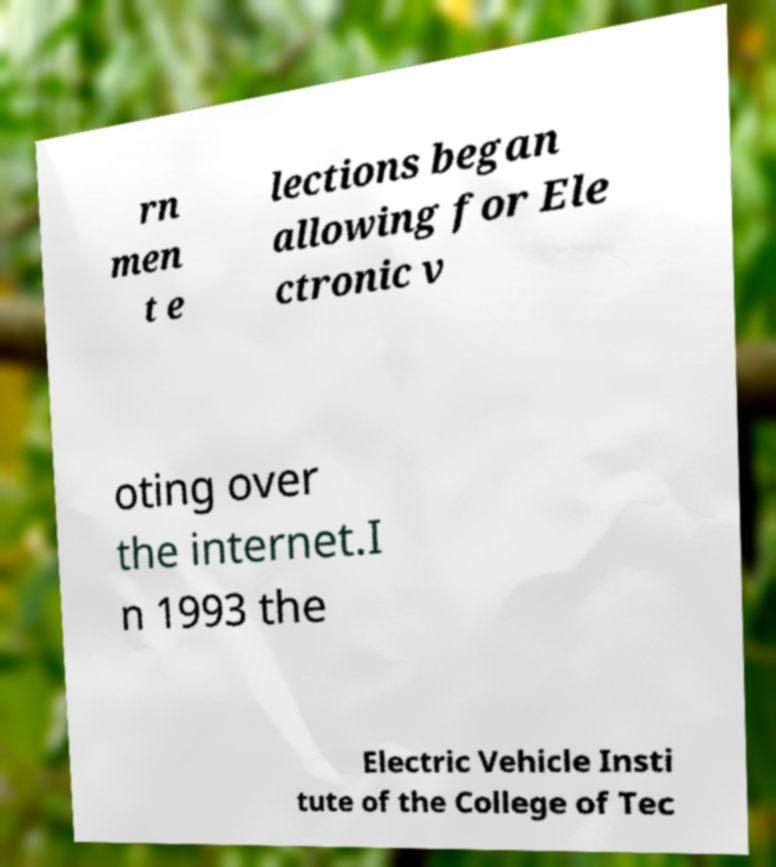I need the written content from this picture converted into text. Can you do that? rn men t e lections began allowing for Ele ctronic v oting over the internet.I n 1993 the Electric Vehicle Insti tute of the College of Tec 